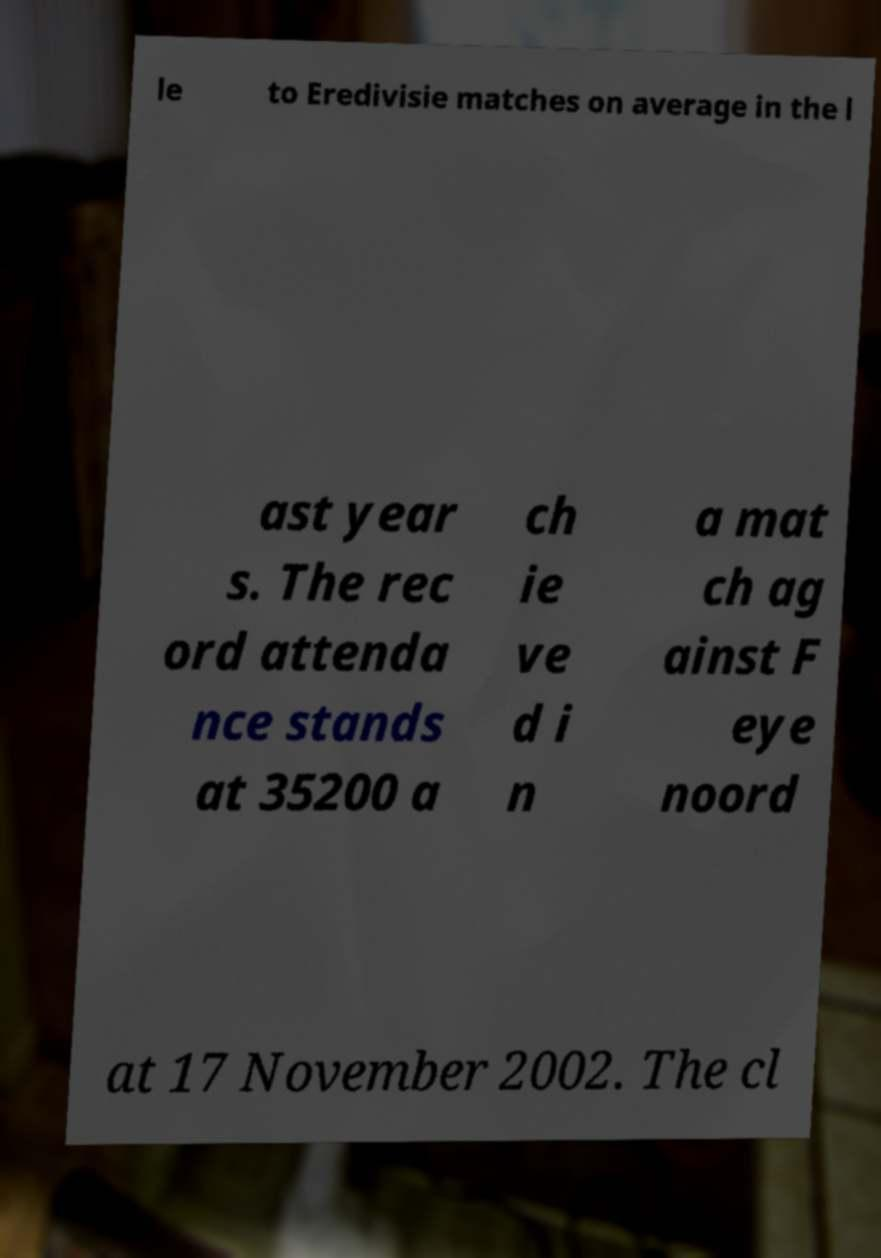Could you assist in decoding the text presented in this image and type it out clearly? le to Eredivisie matches on average in the l ast year s. The rec ord attenda nce stands at 35200 a ch ie ve d i n a mat ch ag ainst F eye noord at 17 November 2002. The cl 